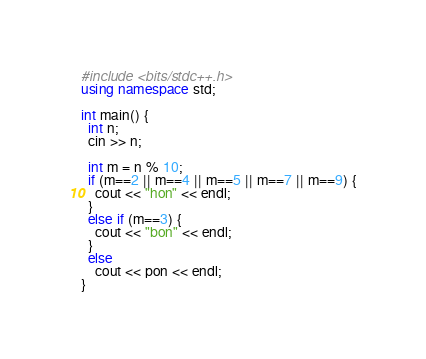<code> <loc_0><loc_0><loc_500><loc_500><_C++_>#include <bits/stdc++.h>
using namespace std;

int main() {
  int n;
  cin >> n;

  int m = n % 10;
  if (m==2 || m==4 || m==5 || m==7 || m==9) {
    cout << "hon" << endl;
  }
  else if (m==3) {
    cout << "bon" << endl;
  }
  else
    cout << pon << endl;
}</code> 